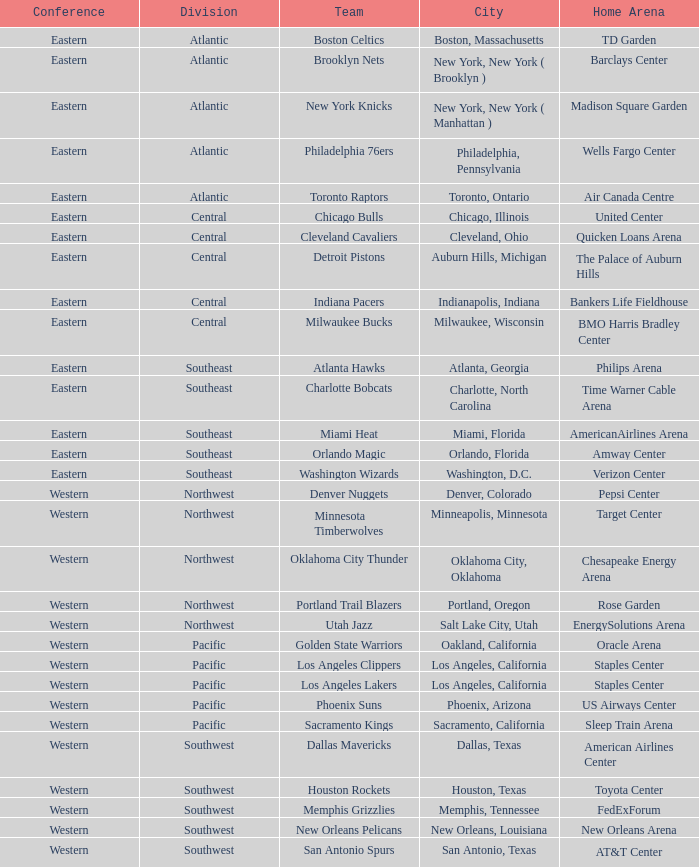Which convention is in portland, oregon? Western. 